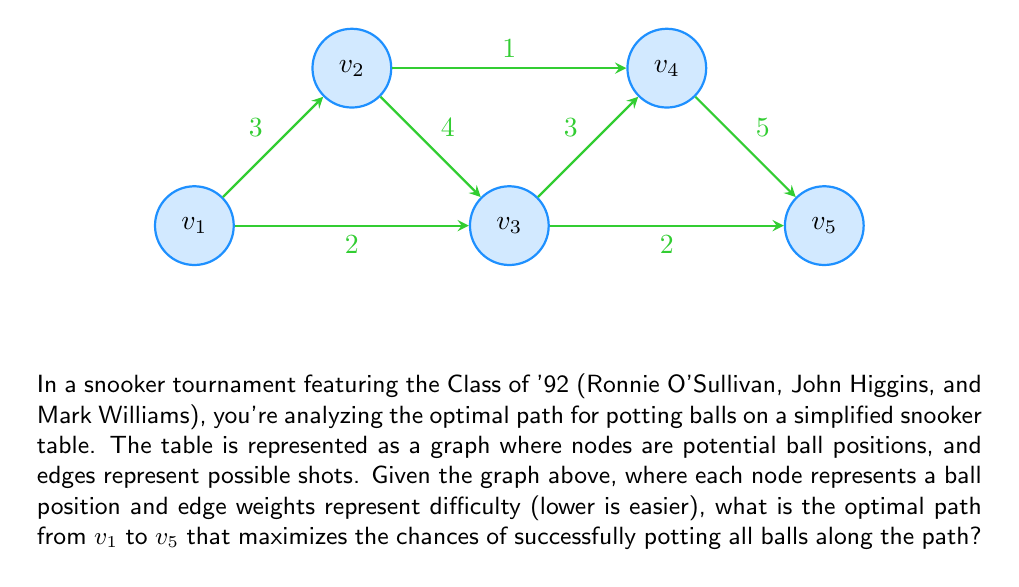Show me your answer to this math problem. To solve this problem, we'll use Dijkstra's algorithm to find the shortest path from $v_1$ to $v_5$, which represents the optimal path for potting balls with the least difficulty.

Step 1: Initialize distances
Set distance to $v_1$ as 0 and all other nodes as infinity.
$d(v_1) = 0$, $d(v_2) = \infty$, $d(v_3) = \infty$, $d(v_4) = \infty$, $d(v_5) = \infty$

Step 2: Visit $v_1$
Update neighbors:
$d(v_2) = \min(\infty, 0 + 3) = 3$
$d(v_3) = \min(\infty, 0 + 2) = 2$

Step 3: Visit $v_3$ (lowest unvisited distance)
Update neighbors:
$d(v_2) = \min(3, 2 + 4) = 3$
$d(v_4) = \min(\infty, 2 + 3) = 5$
$d(v_5) = \min(\infty, 2 + 2) = 4$

Step 4: Visit $v_2$
Update neighbors:
$d(v_4) = \min(5, 3 + 1) = 4$

Step 5: Visit $v_5$ (lowest unvisited distance)
No updates needed.

Step 6: Visit $v_4$
No updates needed.

The shortest path from $v_1$ to $v_5$ is $v_1 \rightarrow v_3 \rightarrow v_5$ with a total difficulty of 4.

This path represents the optimal sequence of shots that a skilled player like those from the Class of '92 would likely choose, balancing difficulty and position for the next shot.
Answer: $v_1 \rightarrow v_3 \rightarrow v_5$ 